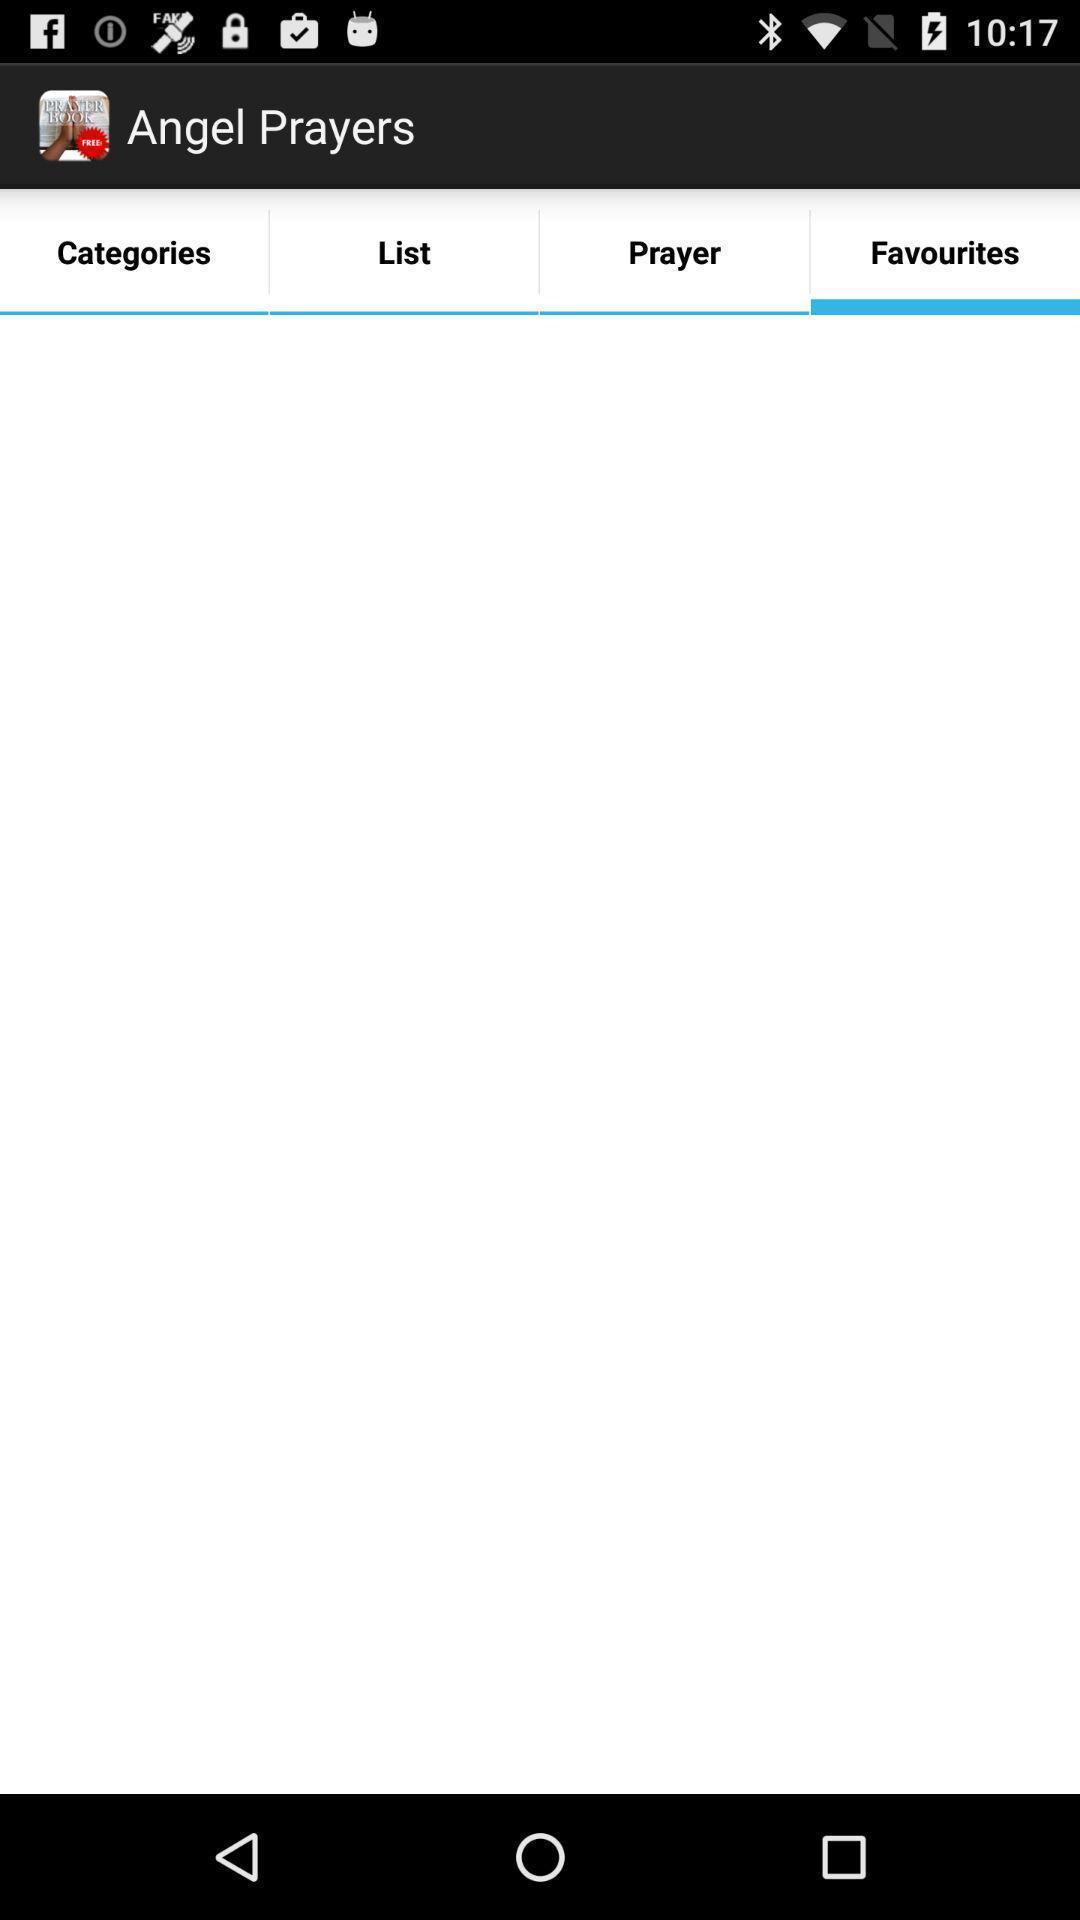Describe this image in words. Screen displaying the favorites page which is empty. 